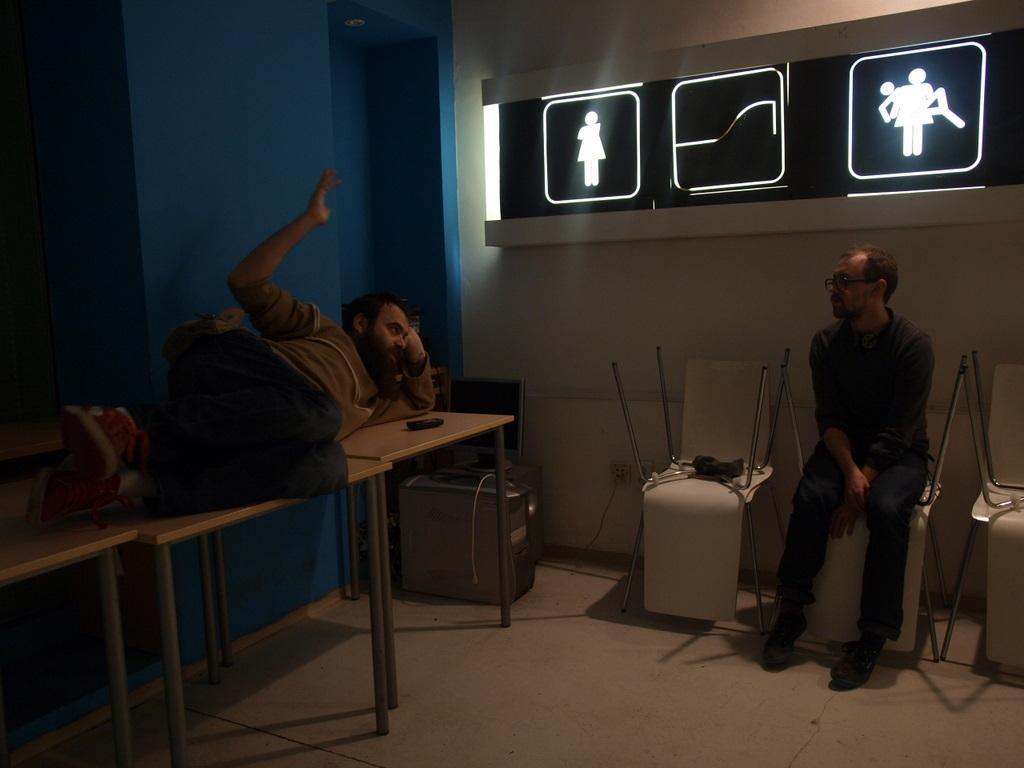How would you summarize this image in a sentence or two? In this image I see 2 men in which this man is sitting over here and this man is lying on these tables and I see few more chairs and I see the wall which is of white and blue in color and I see the floor and I see few depiction pictures of persons. 